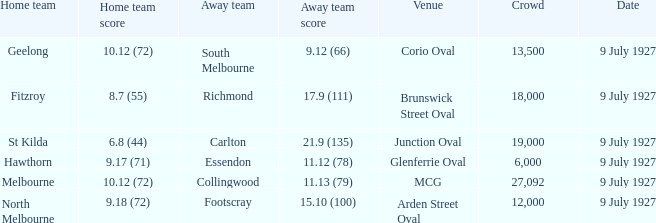How big was the crowd when the away team was Richmond? 18000.0. 